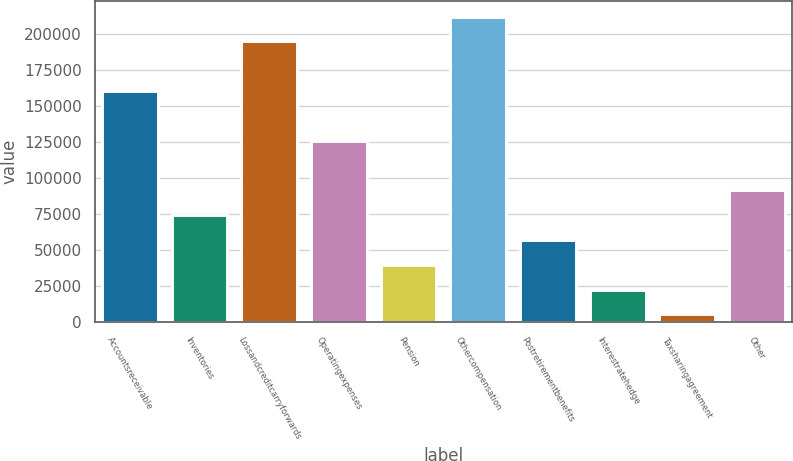Convert chart to OTSL. <chart><loc_0><loc_0><loc_500><loc_500><bar_chart><fcel>Accountsreceivable<fcel>Inventories<fcel>Lossandcreditcarryforwards<fcel>Operatingexpenses<fcel>Pension<fcel>Othercompensation<fcel>Postretirementbenefits<fcel>Interestratehedge<fcel>Taxsharingagreement<fcel>Other<nl><fcel>160482<fcel>74388.8<fcel>194920<fcel>126045<fcel>39951.4<fcel>212138<fcel>57170.1<fcel>22732.7<fcel>5514<fcel>91607.5<nl></chart> 